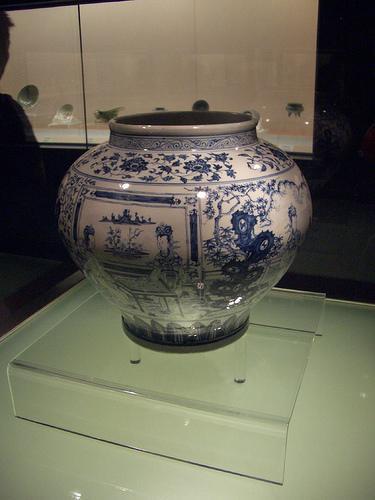How many wheels of the skateboard are touching the ground?
Give a very brief answer. 0. 